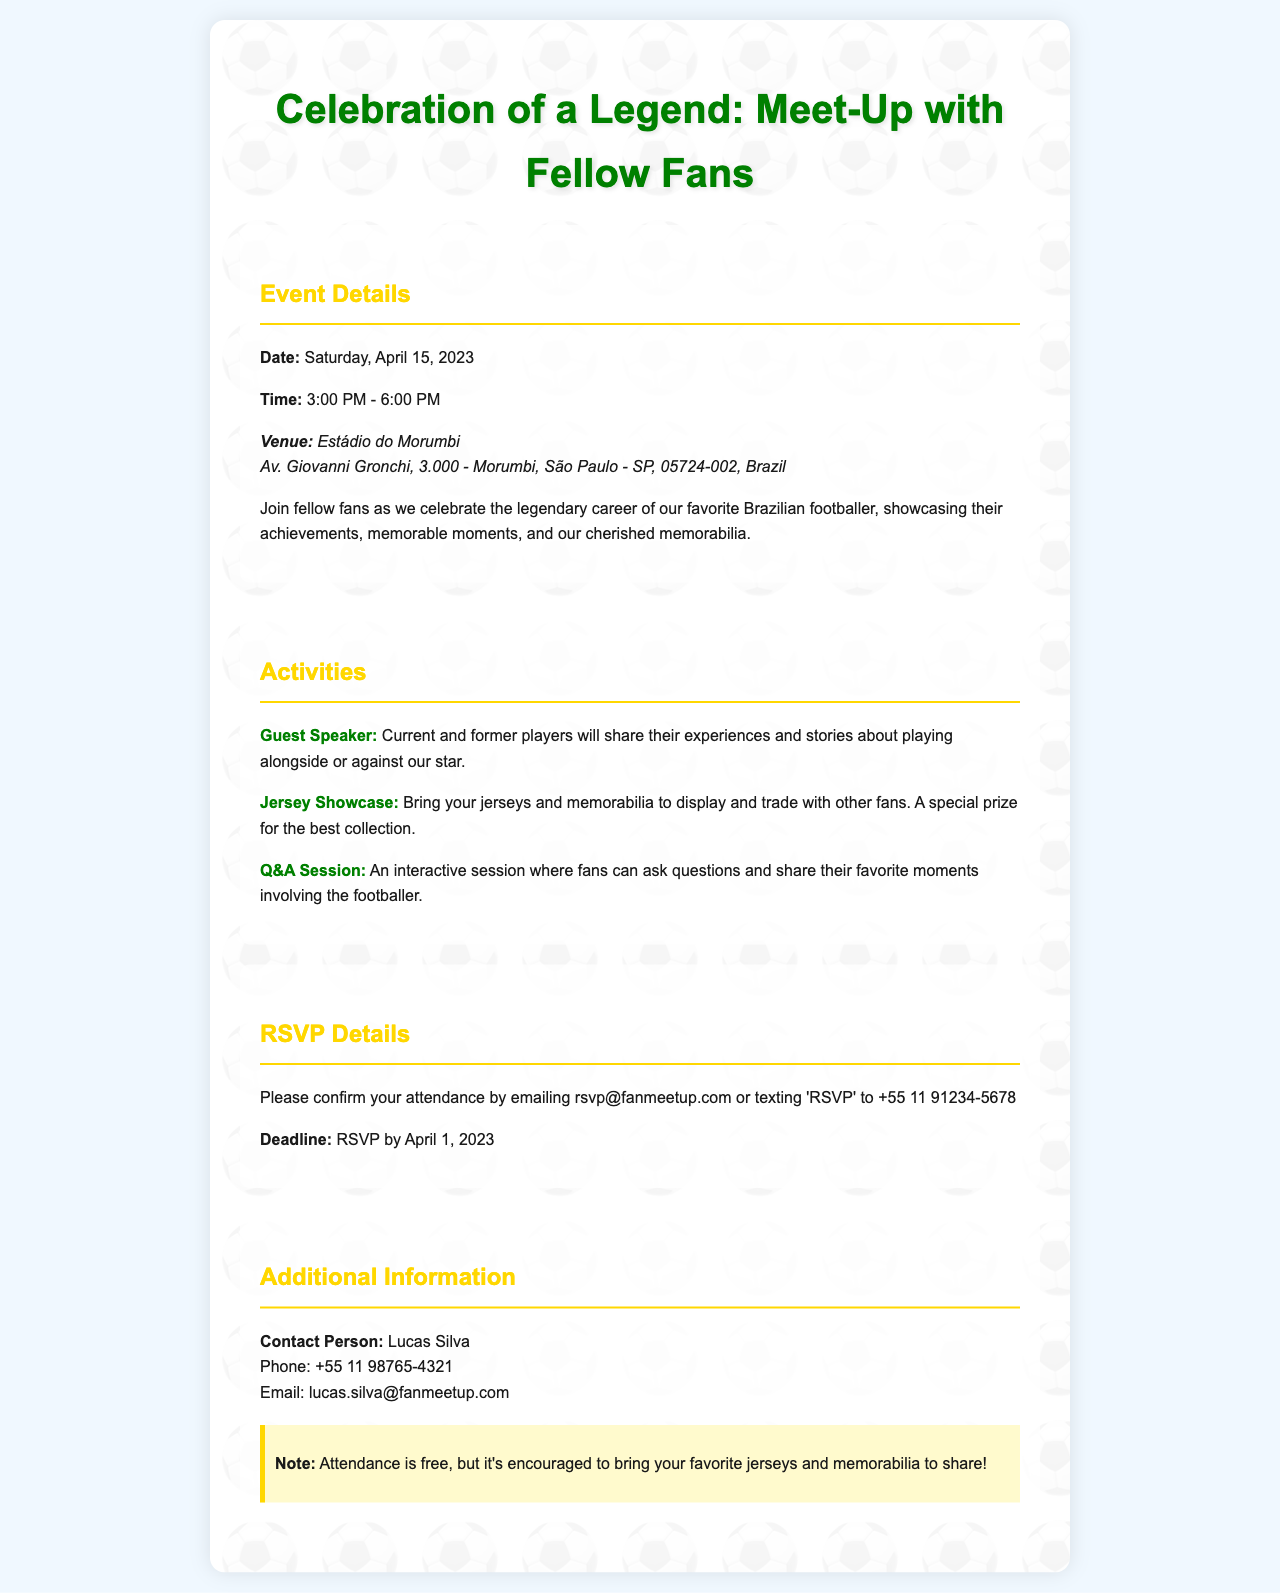what is the date of the event? The event date is explicitly mentioned in the document as Saturday, April 15, 2023.
Answer: Saturday, April 15, 2023 what is the venue of the meet-up? The document specifies the venue details, including the name and address of the location.
Answer: Estádio do Morumbi what time does the event start? The start time of the event is clearly stated as part of the event details.
Answer: 3:00 PM who is the contact person for the event? The document names a specific contact person for any inquiries related to the event.
Answer: Lucas Silva what must attendees do to confirm their attendance? The document outlines the RSVP process for confirming attendance at the event.
Answer: Email or text how long is the meet-up scheduled to last? The duration of the event is mentioned in the time section of the event details.
Answer: 3 hours is there a prize for attendees? The document indicates there is a special prize for a particular activity during the meet-up.
Answer: Yes, for the best collection what is encouraged to bring to the meet-up? The additional information section notes what attendees are encouraged to bring to enhance the experience.
Answer: Jerseys and memorabilia what is the RSVP deadline? The deadline for RSVP confirmations is explicitly stated in the RSVP section.
Answer: April 1, 2023 